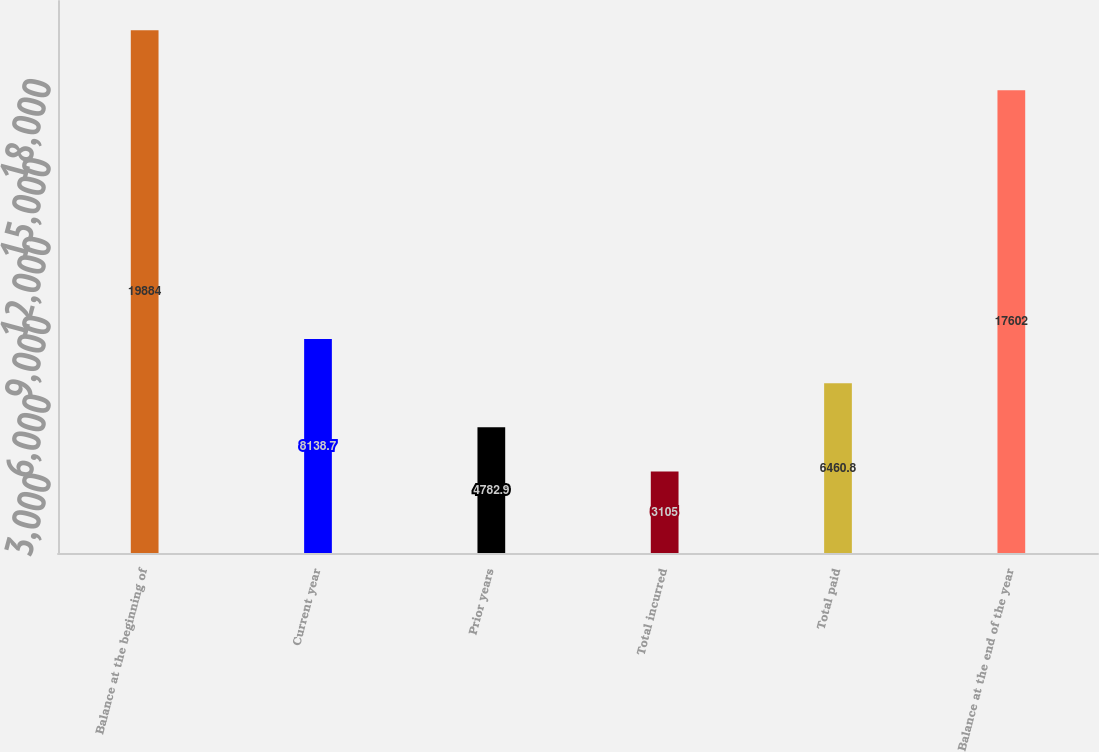<chart> <loc_0><loc_0><loc_500><loc_500><bar_chart><fcel>Balance at the beginning of<fcel>Current year<fcel>Prior years<fcel>Total incurred<fcel>Total paid<fcel>Balance at the end of the year<nl><fcel>19884<fcel>8138.7<fcel>4782.9<fcel>3105<fcel>6460.8<fcel>17602<nl></chart> 